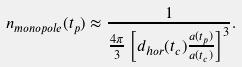Convert formula to latex. <formula><loc_0><loc_0><loc_500><loc_500>n _ { m o n o p o l e } ( t _ { p } ) \approx \frac { 1 } { \frac { 4 \pi } { 3 } \left [ d _ { h o r } ( t _ { c } ) \frac { a ( t _ { p } ) } { a ( t _ { c } ) } \right ] ^ { 3 } } .</formula> 